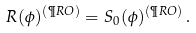<formula> <loc_0><loc_0><loc_500><loc_500>R ( \phi ) ^ { ( \P R O ) } = S _ { 0 } ( \phi ) ^ { ( \P R O ) } \, .</formula> 